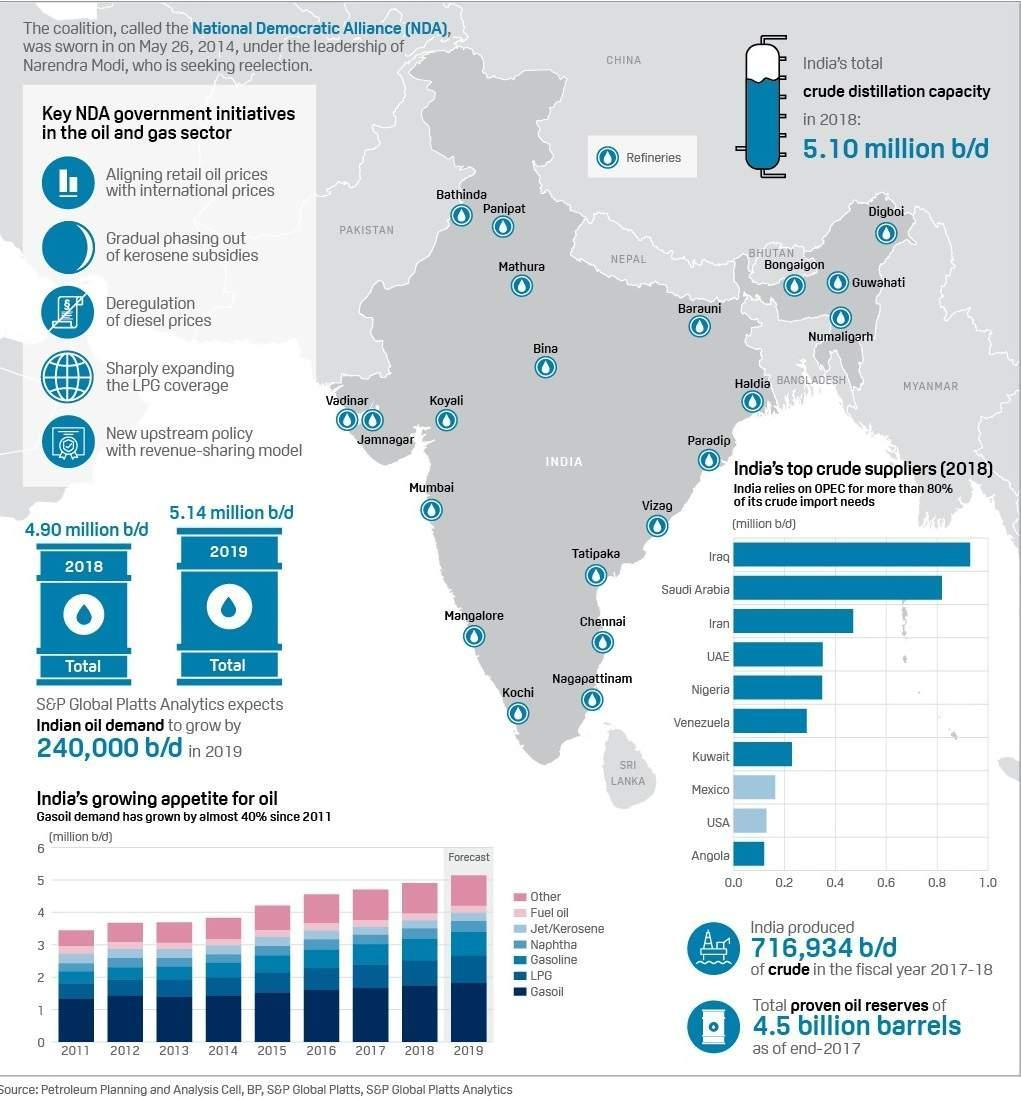Which countries have crude oil suppliers above 0.8 million b/d?
Answer the question with a short phrase. Iraq, Saudi Arabia How many countries have crude oil suppliers above 0.4 million b/d? 3 How many countries have crude oil suppliers above 0.8 million b/d? 2 